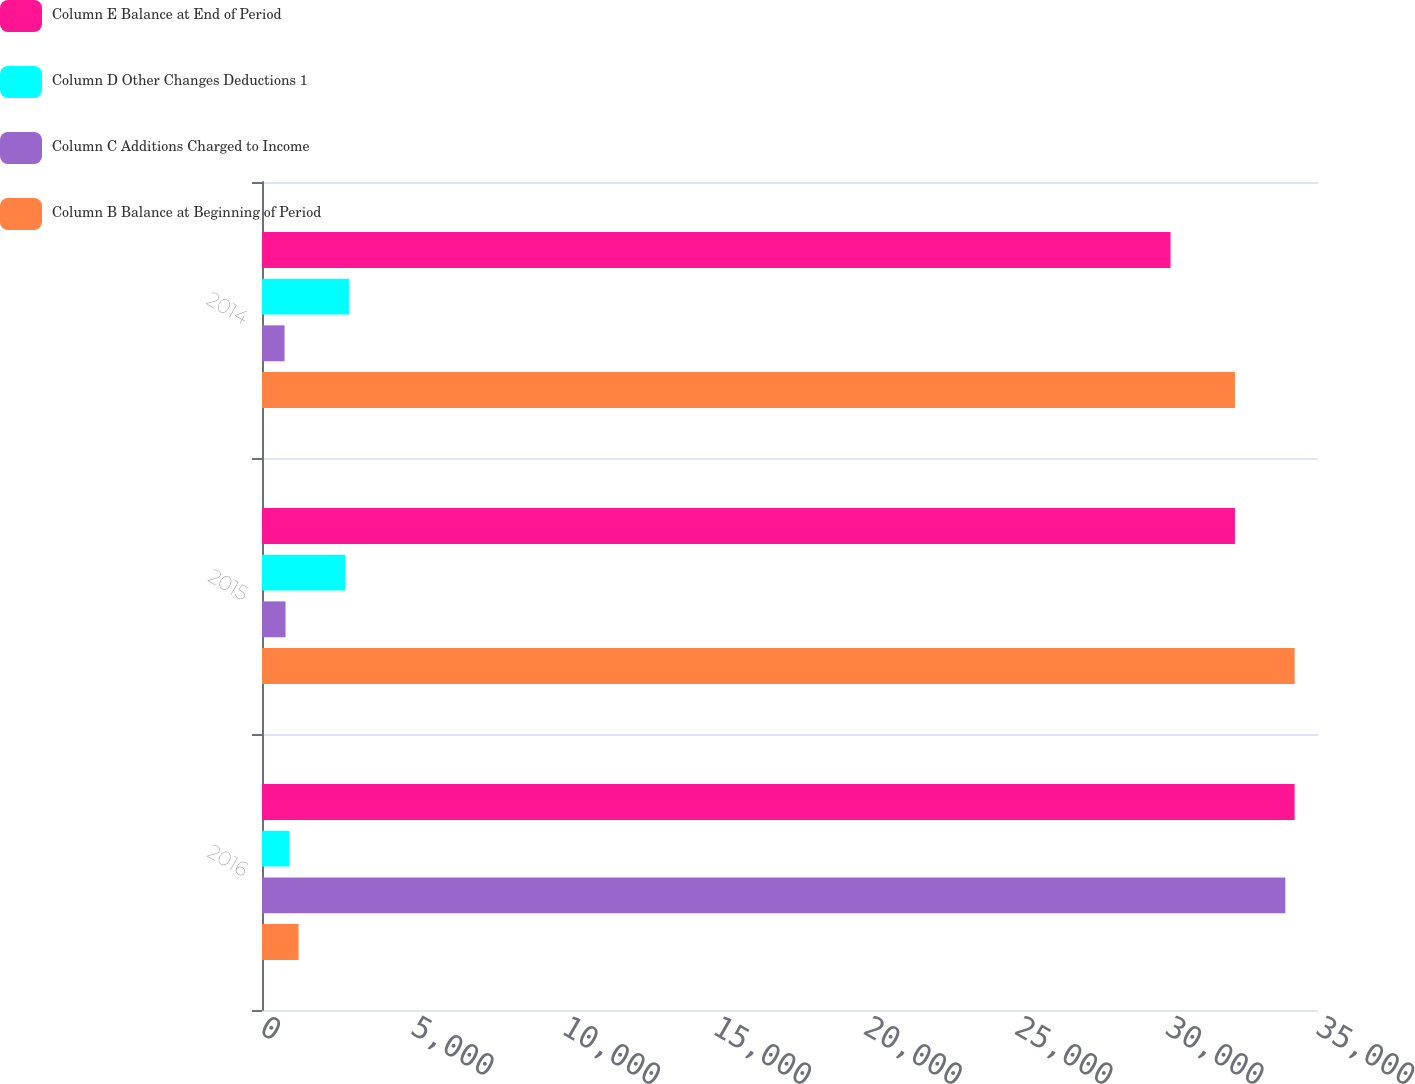Convert chart to OTSL. <chart><loc_0><loc_0><loc_500><loc_500><stacked_bar_chart><ecel><fcel>2016<fcel>2015<fcel>2014<nl><fcel>Column E Balance at End of Period<fcel>34226<fcel>32247<fcel>30113<nl><fcel>Column D Other Changes Deductions 1<fcel>902<fcel>2759<fcel>2881<nl><fcel>Column C Additions Charged to Income<fcel>33917<fcel>780<fcel>747<nl><fcel>Column B Balance at Beginning of Period<fcel>1211<fcel>34226<fcel>32247<nl></chart> 